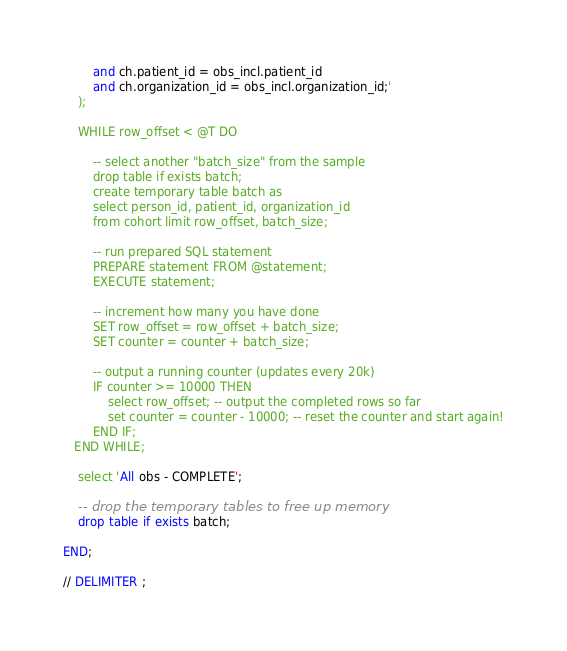<code> <loc_0><loc_0><loc_500><loc_500><_SQL_>        and ch.patient_id = obs_incl.patient_id
        and ch.organization_id = obs_incl.organization_id;'
	);

    WHILE row_offset < @T DO

        -- select another "batch_size" from the sample
        drop table if exists batch;
        create temporary table batch as
        select person_id, patient_id, organization_id
        from cohort limit row_offset, batch_size;

		-- run prepared SQL statement
		PREPARE statement FROM @statement;
        EXECUTE statement;

        -- increment how many you have done
        SET row_offset = row_offset + batch_size;
        SET counter = counter + batch_size;

        -- output a running counter (updates every 20k)
        IF counter >= 10000 THEN
			select row_offset; -- output the completed rows so far
            set counter = counter - 10000; -- reset the counter and start again!
		END IF;
   END WHILE;

	select 'All obs - COMPLETE';

    -- drop the temporary tables to free up memory
    drop table if exists batch;

END;

// DELIMITER ;
</code> 